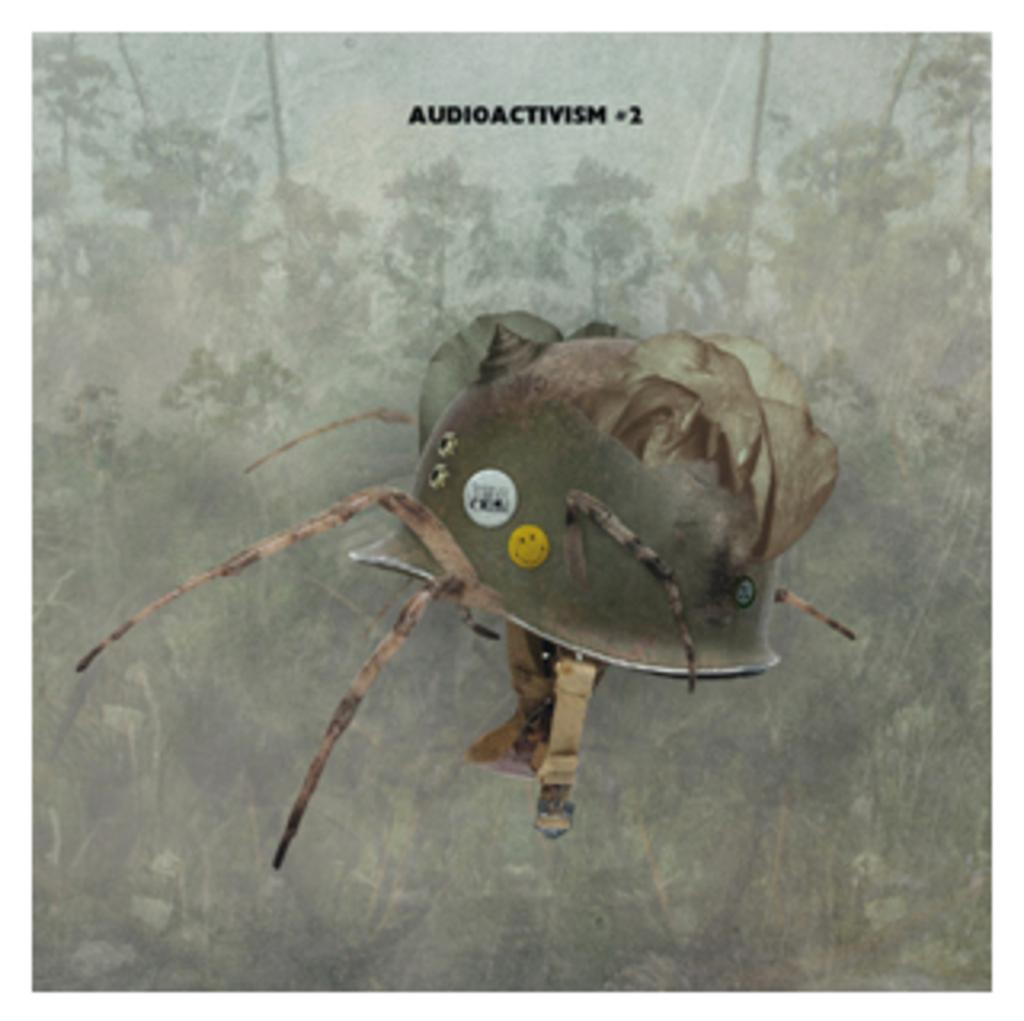What can be observed about the image's appearance? The image appears to be edited. What object is present in the image? There is a helmet in the image. What type of natural elements can be seen in the background of the image? There are trees and plants in the background of the image. Is there any text or logo visible on the image? Yes, there is a watermark on the image. How does the zephyr affect the helmet in the image? There is no zephyr present in the image, so its effect on the helmet cannot be determined. 